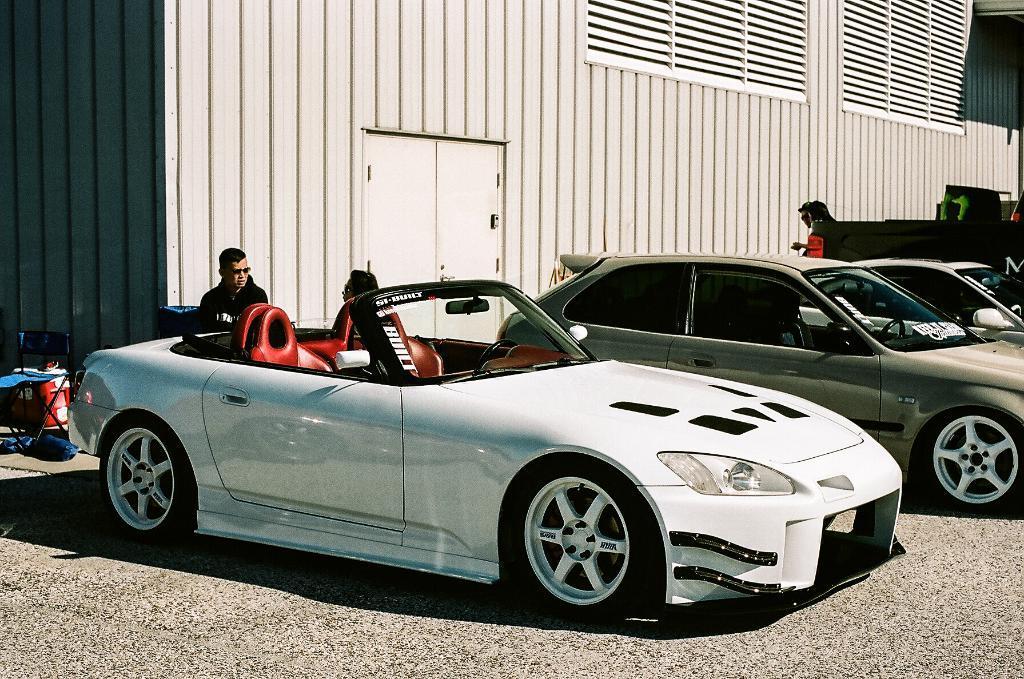Describe this image in one or two sentences. In this picture I can see few cars and I can see building and I can see a man standing and looks like couple of them are sitting on the chairs and another empty chair on the left side of the picture. 